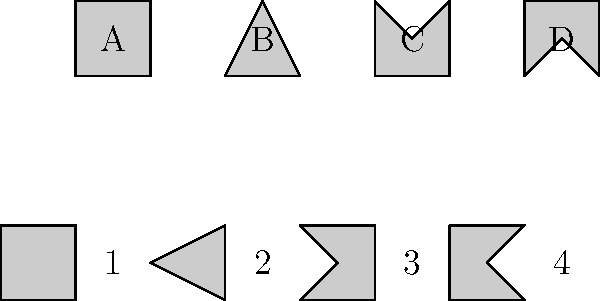The firewall rule patterns above represent different security configurations. The top row (A-D) shows the original patterns, while the bottom row (1-4) shows the same patterns rotated 90 degrees clockwise. Which rotated pattern corresponds to the original pattern C? To solve this problem, we need to mentally rotate each pattern in the top row by 90 degrees clockwise and compare it with the patterns in the bottom row. Let's go through this process step-by-step:

1. Identify pattern C in the top row. It's a pentagon-like shape with a point facing downwards.

2. Mentally rotate pattern C 90 degrees clockwise. This would result in a pentagon-like shape with a point facing to the left.

3. Compare this mentally rotated shape with the patterns in the bottom row:
   - Pattern 1 is a square, which doesn't match.
   - Pattern 2 is a triangle, which doesn't match.
   - Pattern 3 is a pentagon-like shape with a point facing to the left, which matches our mental rotation of pattern C.
   - Pattern 4 is a quadrilateral with a diagonal, which doesn't match.

4. Therefore, the rotated pattern that corresponds to the original pattern C is pattern 3.

This spatial reasoning exercise is relevant to cybersecurity as it simulates the process of recognizing and matching complex firewall rule patterns, which might be necessary when analyzing security configurations across different systems or when identifying potential security breaches based on pattern recognition.
Answer: 3 